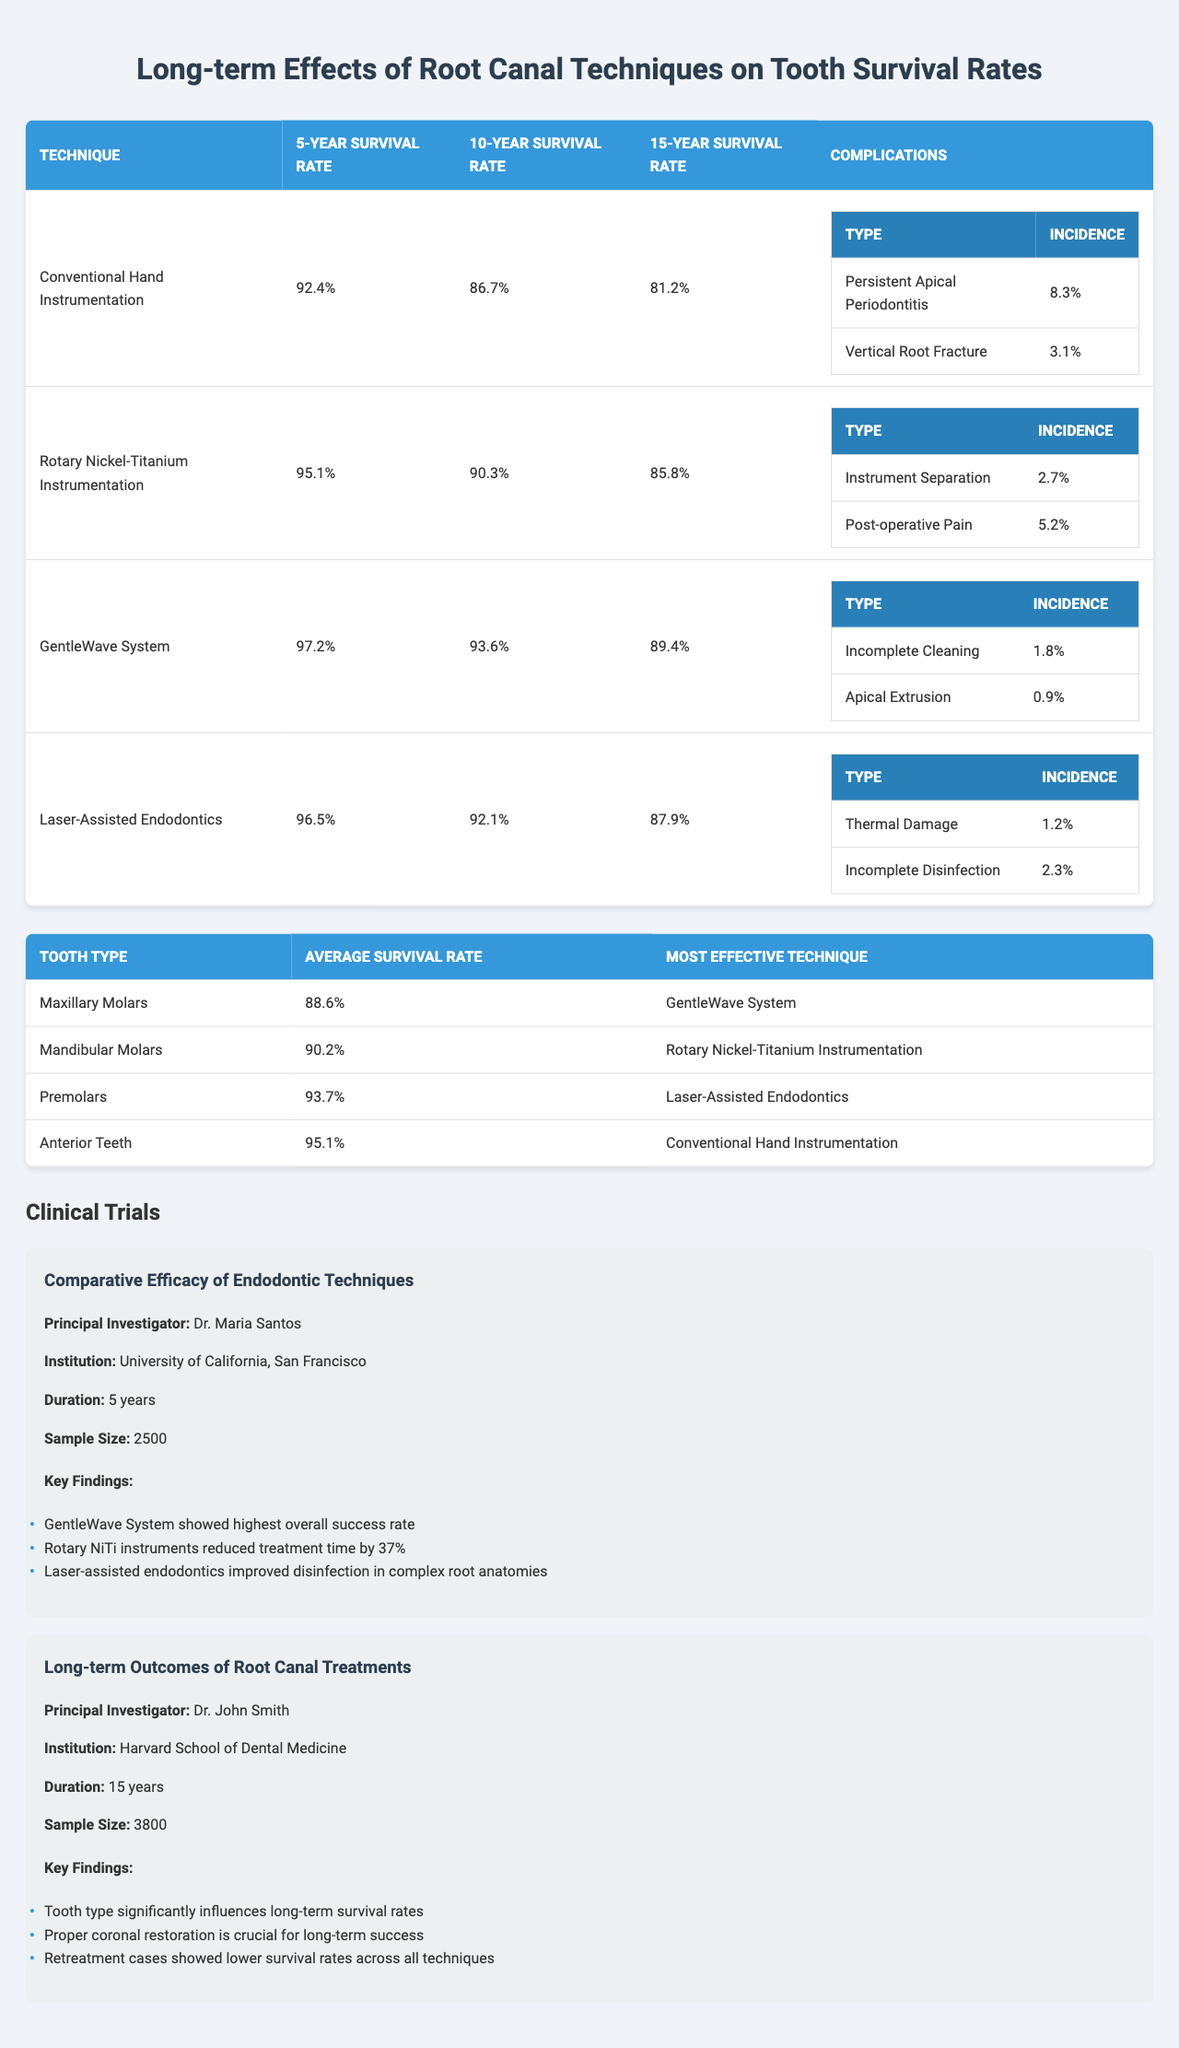What is the 10-year survival rate of the GentleWave System? The table indicates that the 10-year survival rate for the GentleWave System is 93.6%.
Answer: 93.6% Which root canal technique has the lowest 5-year survival rate? The Conventional Hand Instrumentation technique has the lowest 5-year survival rate at 92.4%.
Answer: 92.4% How many root canal techniques have a 15-year survival rate of 85% or higher? Three techniques (Rotary Nickel-Titanium Instrumentation, GentleWave System, and Laser-Assisted Endodontics) have 15-year survival rates of 85% or higher.
Answer: 3 What is the average survival rate for maxillary molars? The table states that the average survival rate for maxillary molars is 88.6%.
Answer: 88.6% Is the incidence of thermal damage higher than that of apical extrusion? The incidence of thermal damage is 1.2% while the incidence of apical extrusion is 0.9%, making thermal damage higher.
Answer: Yes Which technique had the highest 5-year survival rate? The GentleWave System had the highest 5-year survival rate at 97.2%.
Answer: 97.2% Comparing tooth types, which one has the most effective technique? Anterior teeth are most effectively treated with the Conventional Hand Instrumentation technique.
Answer: Conventional Hand Instrumentation If we sum the incidences of all complications for Rotary Nickel-Titanium Instrumentation, what is the total? The total incidence is calculated as 2.7% (Instrument Separation) + 5.2% (Post-operative Pain) = 7.9%.
Answer: 7.9% What is the key finding from the trial "Comparative Efficacy of Endodontic Techniques"? Among the key findings, it states that the GentleWave System showed the highest overall success rate.
Answer: GentleWave System showed highest overall success rate Which tooth type has the lowest average survival rate? The maxillary molars have the lowest average survival rate at 88.6%.
Answer: 88.6% 